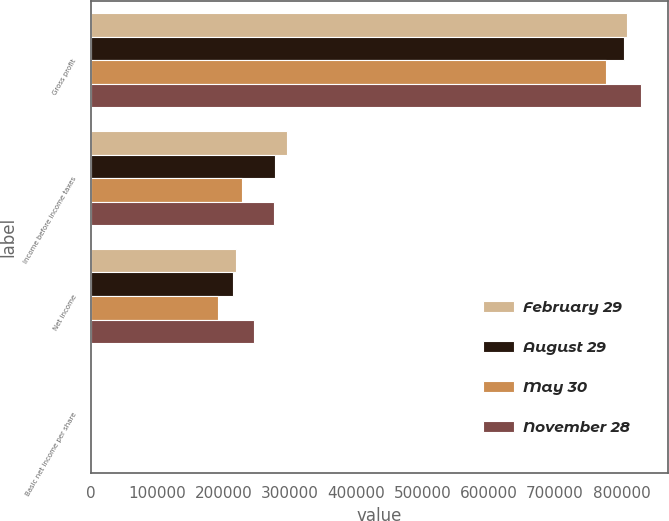<chart> <loc_0><loc_0><loc_500><loc_500><stacked_bar_chart><ecel><fcel>Gross profit<fcel>Income before income taxes<fcel>Net income<fcel>Basic net income per share<nl><fcel>February 29<fcel>807970<fcel>295644<fcel>219379<fcel>0.39<nl><fcel>August 29<fcel>804020<fcel>278006<fcel>214910<fcel>0.4<nl><fcel>May 30<fcel>776406<fcel>228514<fcel>191608<fcel>0.36<nl><fcel>November 28<fcel>828863<fcel>276344<fcel>245917<fcel>0.47<nl></chart> 